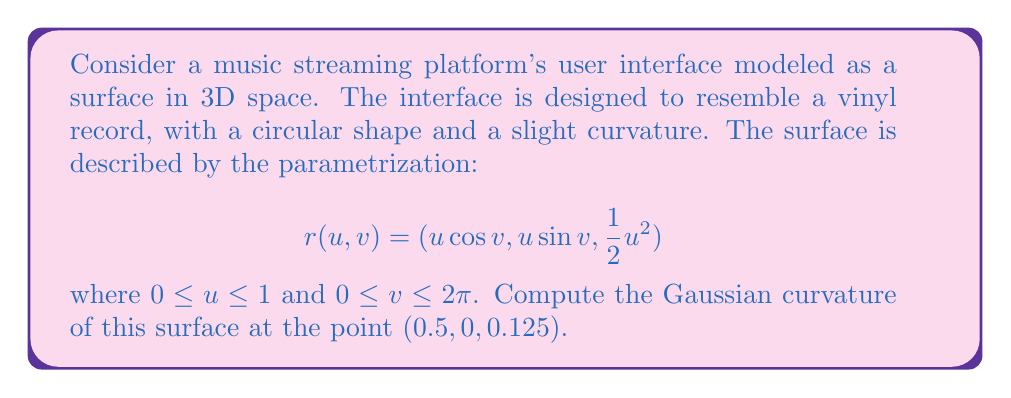Provide a solution to this math problem. To compute the Gaussian curvature, we need to follow these steps:

1. Calculate the first fundamental form coefficients E, F, and G.
2. Calculate the second fundamental form coefficients L, M, and N.
3. Use these coefficients to compute the Gaussian curvature.

Step 1: First fundamental form coefficients

$$r_u = (\cos v, \sin v, u)$$
$$r_v = (-u \sin v, u \cos v, 0)$$

$$E = r_u \cdot r_u = \cos^2 v + \sin^2 v + u^2 = 1 + u^2$$
$$F = r_u \cdot r_v = 0$$
$$G = r_v \cdot r_v = u^2$$

Step 2: Second fundamental form coefficients

$$r_{uu} = (0, 0, 1)$$
$$r_{uv} = (-\sin v, \cos v, 0)$$
$$r_{vv} = (-u \cos v, -u \sin v, 0)$$

$$\mathbf{n} = \frac{r_u \times r_v}{|r_u \times r_v|} = \frac{(-u \cos v, -u \sin v, 1)}{\sqrt{1 + u^2}}$$

$$L = r_{uu} \cdot \mathbf{n} = \frac{1}{\sqrt{1 + u^2}}$$
$$M = r_{uv} \cdot \mathbf{n} = 0$$
$$N = r_{vv} \cdot \mathbf{n} = \frac{-u^2}{\sqrt{1 + u^2}}$$

Step 3: Gaussian curvature

The Gaussian curvature K is given by:

$$K = \frac{LN - M^2}{EG - F^2}$$

Substituting the values:

$$K = \frac{\frac{1}{\sqrt{1 + u^2}} \cdot \frac{-u^2}{\sqrt{1 + u^2}} - 0^2}{(1 + u^2) \cdot u^2 - 0^2} = \frac{-u^2}{(1 + u^2)^2 \cdot u^2} = \frac{-1}{(1 + u^2)^2}$$

At the point $(0.5, 0, 0.125)$, we have $u = 0.5$ and $v = 0$. Substituting $u = 0.5$ into the formula:

$$K = \frac{-1}{(1 + 0.5^2)^2} = \frac{-1}{(1.25)^2} = -0.64$$
Answer: $K = -0.64$ 